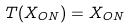Convert formula to latex. <formula><loc_0><loc_0><loc_500><loc_500>T ( X _ { O N } ) = X _ { O N }</formula> 